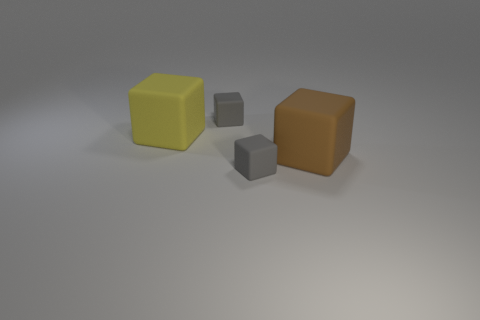Add 3 rubber cubes. How many objects exist? 7 Subtract 0 gray cylinders. How many objects are left? 4 Subtract all brown rubber blocks. Subtract all small matte objects. How many objects are left? 1 Add 2 gray cubes. How many gray cubes are left? 4 Add 1 gray matte objects. How many gray matte objects exist? 3 